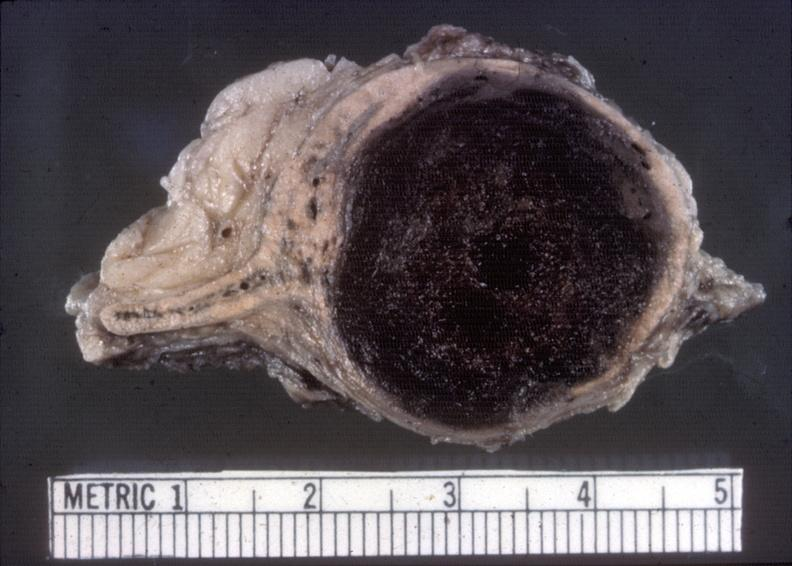where does this belong to?
Answer the question using a single word or phrase. Endocrine system 